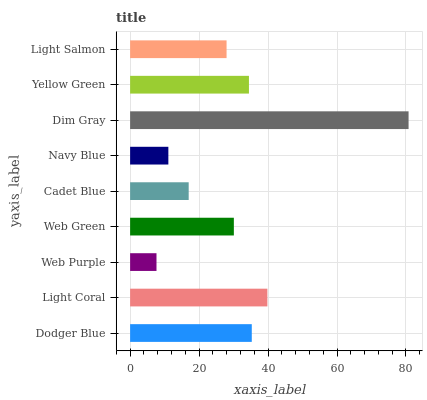Is Web Purple the minimum?
Answer yes or no. Yes. Is Dim Gray the maximum?
Answer yes or no. Yes. Is Light Coral the minimum?
Answer yes or no. No. Is Light Coral the maximum?
Answer yes or no. No. Is Light Coral greater than Dodger Blue?
Answer yes or no. Yes. Is Dodger Blue less than Light Coral?
Answer yes or no. Yes. Is Dodger Blue greater than Light Coral?
Answer yes or no. No. Is Light Coral less than Dodger Blue?
Answer yes or no. No. Is Web Green the high median?
Answer yes or no. Yes. Is Web Green the low median?
Answer yes or no. Yes. Is Yellow Green the high median?
Answer yes or no. No. Is Dim Gray the low median?
Answer yes or no. No. 